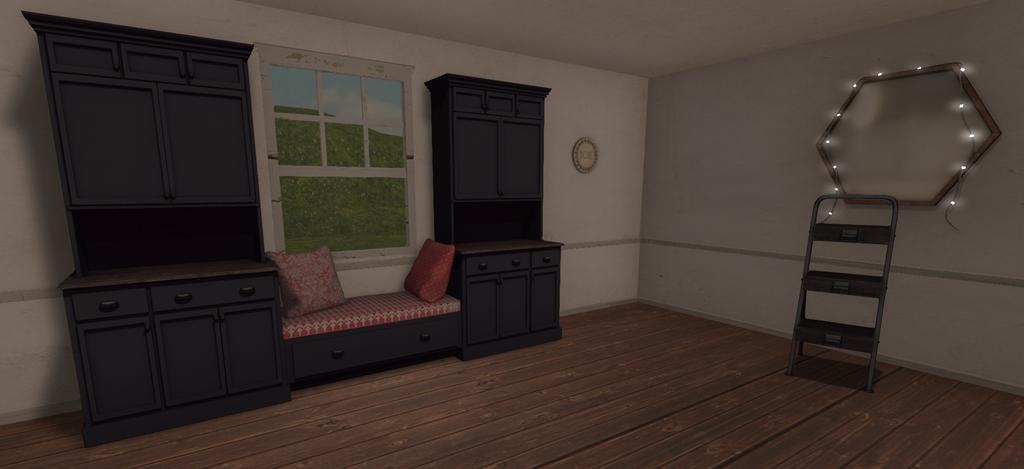Can you describe this image briefly? In this picture I can see a depiction picture, where I can see 2 cupboards, a sofa and on it I can see 2 cushions and I can see a stand and I see the floor. On the right side of this image, I can see the lights and a thing on the wall. In the middle of this picture I can see the window and through the window I can see the grass and the sky. 